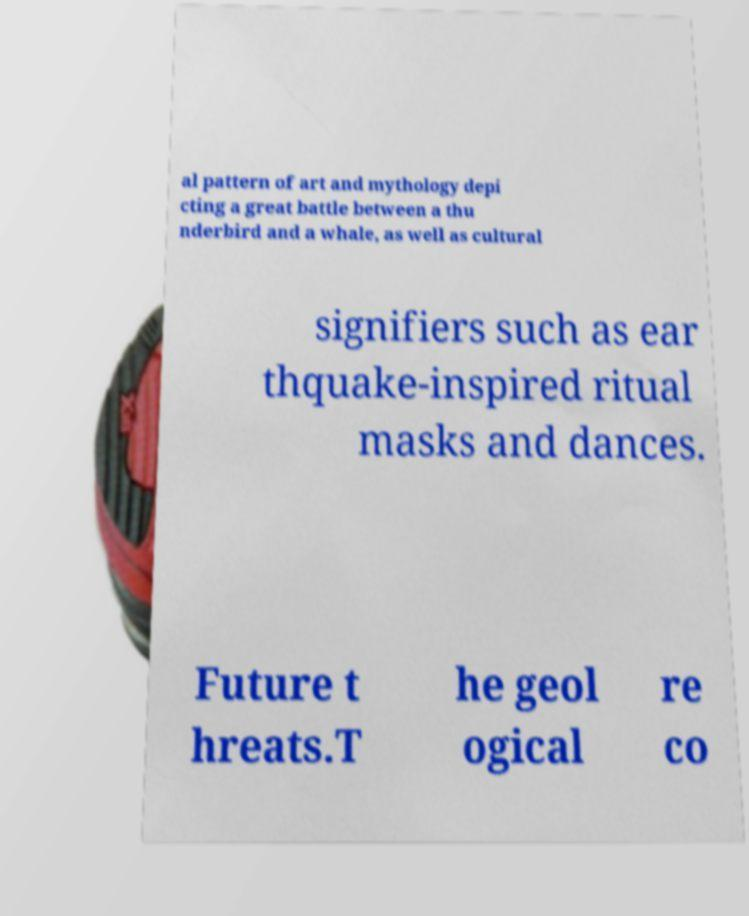Could you assist in decoding the text presented in this image and type it out clearly? al pattern of art and mythology depi cting a great battle between a thu nderbird and a whale, as well as cultural signifiers such as ear thquake-inspired ritual masks and dances. Future t hreats.T he geol ogical re co 